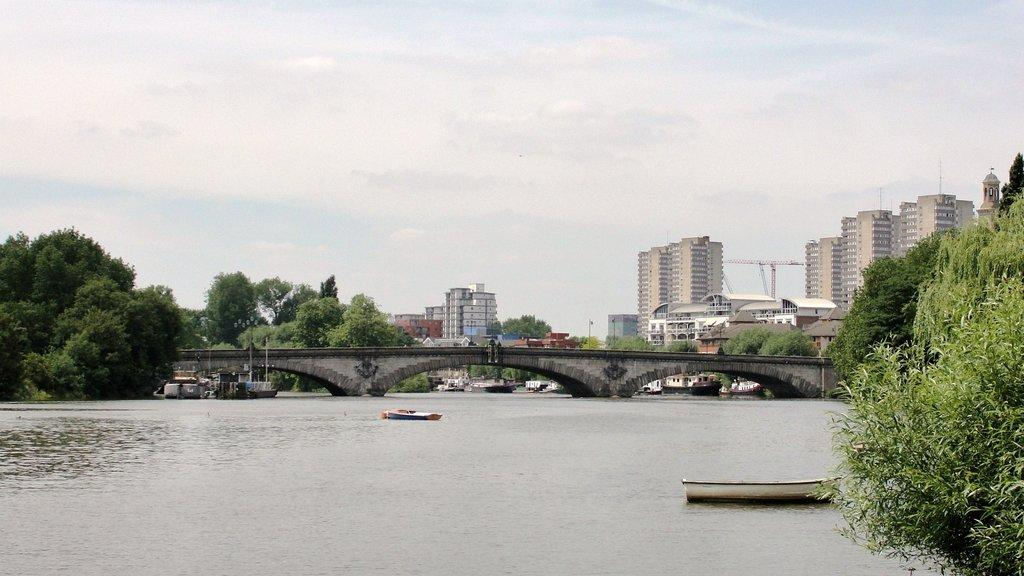What is on the water in the image? There are boats on the water in the image. What type of natural elements can be seen in the image? There are trees visible in the image. What type of man-made structures are present in the image? There are buildings in the image. What type of machinery is present in the image? A crane is present in the image. What connects the two sides of the water in the image? There is a bridge over the water in the image. Where is the shelf located in the image? There is no shelf present in the image. What type of wound can be seen on the crane in the image? There is no wound present on the crane in the image. 